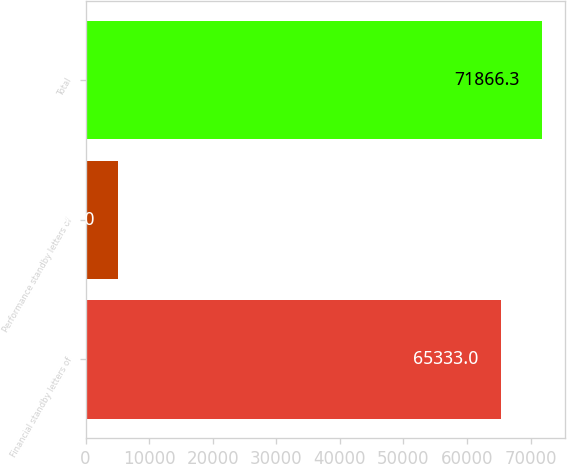Convert chart. <chart><loc_0><loc_0><loc_500><loc_500><bar_chart><fcel>Financial standby letters of<fcel>Performance standby letters of<fcel>Total<nl><fcel>65333<fcel>5157<fcel>71866.3<nl></chart> 